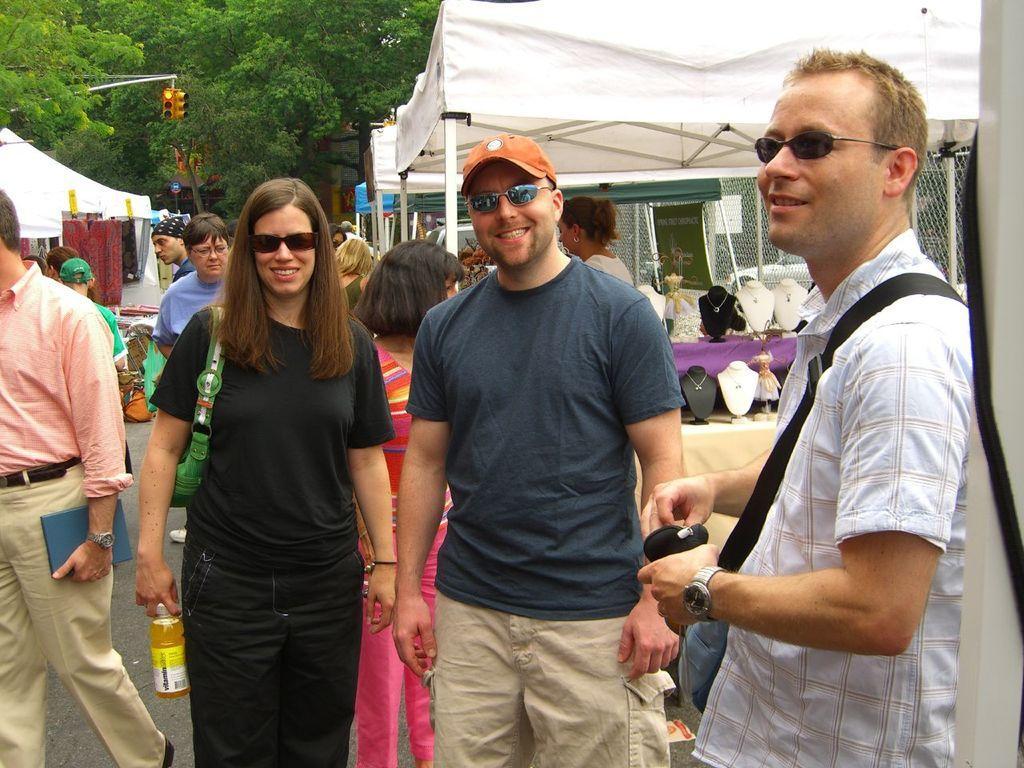Describe this image in one or two sentences. This picture shows few people Standing and we see a woman holding a bottle in her hand and we see a man holding a book in his hand and we see three people wore sunglasses on their faces and a man wore a cap on his head and we see tents and few people standing and watching the stores and we see a traffic signal light to the pole and trees and and we see a man wore a bag. 